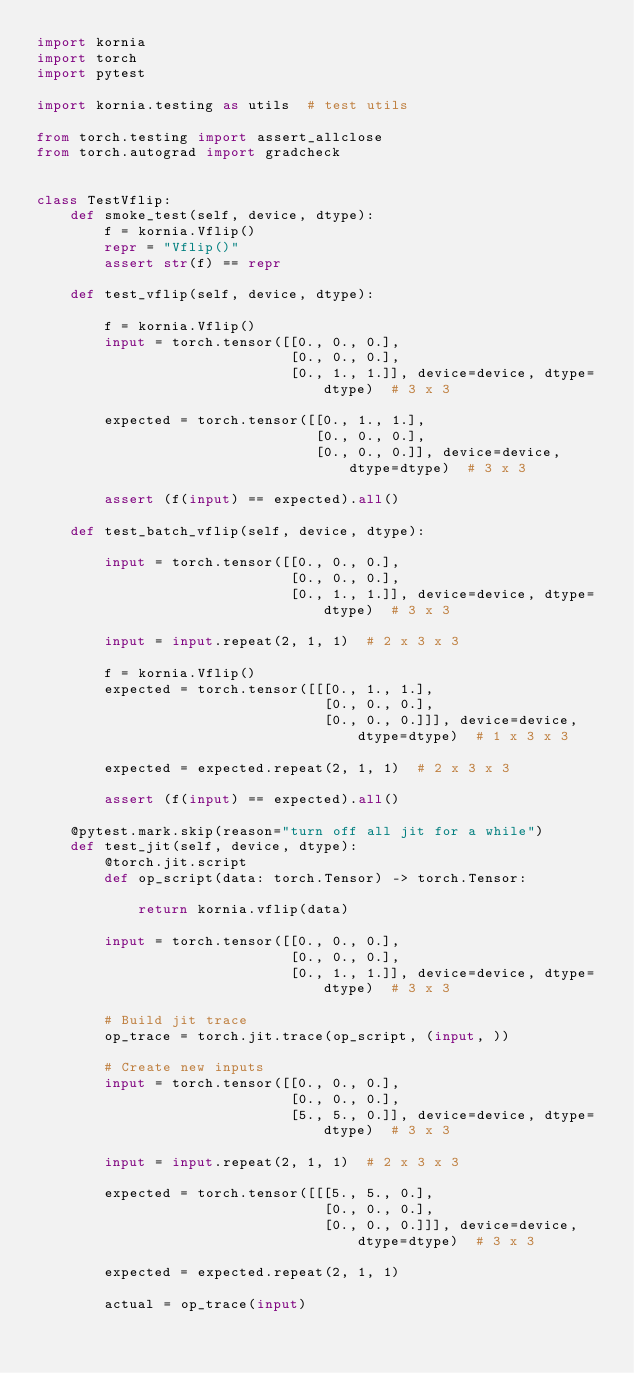<code> <loc_0><loc_0><loc_500><loc_500><_Python_>import kornia
import torch
import pytest

import kornia.testing as utils  # test utils

from torch.testing import assert_allclose
from torch.autograd import gradcheck


class TestVflip:
    def smoke_test(self, device, dtype):
        f = kornia.Vflip()
        repr = "Vflip()"
        assert str(f) == repr

    def test_vflip(self, device, dtype):

        f = kornia.Vflip()
        input = torch.tensor([[0., 0., 0.],
                              [0., 0., 0.],
                              [0., 1., 1.]], device=device, dtype=dtype)  # 3 x 3

        expected = torch.tensor([[0., 1., 1.],
                                 [0., 0., 0.],
                                 [0., 0., 0.]], device=device, dtype=dtype)  # 3 x 3

        assert (f(input) == expected).all()

    def test_batch_vflip(self, device, dtype):

        input = torch.tensor([[0., 0., 0.],
                              [0., 0., 0.],
                              [0., 1., 1.]], device=device, dtype=dtype)  # 3 x 3

        input = input.repeat(2, 1, 1)  # 2 x 3 x 3

        f = kornia.Vflip()
        expected = torch.tensor([[[0., 1., 1.],
                                  [0., 0., 0.],
                                  [0., 0., 0.]]], device=device, dtype=dtype)  # 1 x 3 x 3

        expected = expected.repeat(2, 1, 1)  # 2 x 3 x 3

        assert (f(input) == expected).all()

    @pytest.mark.skip(reason="turn off all jit for a while")
    def test_jit(self, device, dtype):
        @torch.jit.script
        def op_script(data: torch.Tensor) -> torch.Tensor:

            return kornia.vflip(data)

        input = torch.tensor([[0., 0., 0.],
                              [0., 0., 0.],
                              [0., 1., 1.]], device=device, dtype=dtype)  # 3 x 3

        # Build jit trace
        op_trace = torch.jit.trace(op_script, (input, ))

        # Create new inputs
        input = torch.tensor([[0., 0., 0.],
                              [0., 0., 0.],
                              [5., 5., 0.]], device=device, dtype=dtype)  # 3 x 3

        input = input.repeat(2, 1, 1)  # 2 x 3 x 3

        expected = torch.tensor([[[5., 5., 0.],
                                  [0., 0., 0.],
                                  [0., 0., 0.]]], device=device, dtype=dtype)  # 3 x 3

        expected = expected.repeat(2, 1, 1)

        actual = op_trace(input)
</code> 